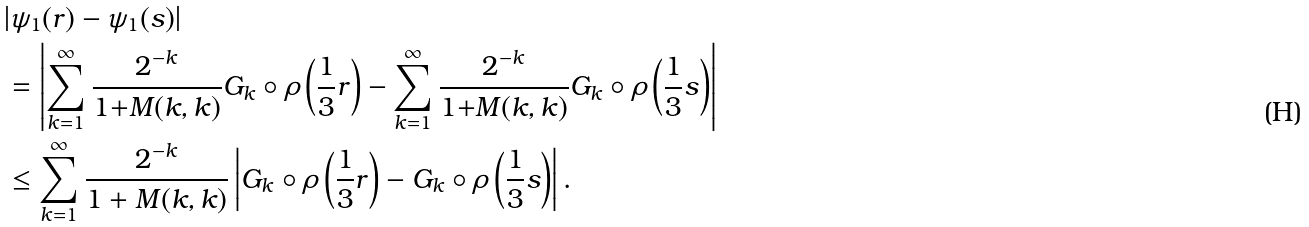Convert formula to latex. <formula><loc_0><loc_0><loc_500><loc_500>& | \psi _ { 1 } ( r ) - \psi _ { 1 } ( s ) | \\ & = \left | \sum _ { k = 1 } ^ { \infty } \frac { 2 ^ { - k } } { 1 { + } M ( k , k ) } G _ { k } \circ \rho \left ( \frac { 1 } { 3 } r \right ) - \sum _ { k = 1 } ^ { \infty } \frac { 2 ^ { - k } } { 1 { + } M ( k , k ) } G _ { k } \circ \rho \left ( \frac { 1 } { 3 } s \right ) \right | \\ & \leq \sum _ { k = 1 } ^ { \infty } \frac { 2 ^ { - k } } { 1 + M ( k , k ) } \left | G _ { k } \circ \rho \left ( \frac { 1 } { 3 } r \right ) - G _ { k } \circ \rho \left ( \frac { 1 } { 3 } s \right ) \right | .</formula> 